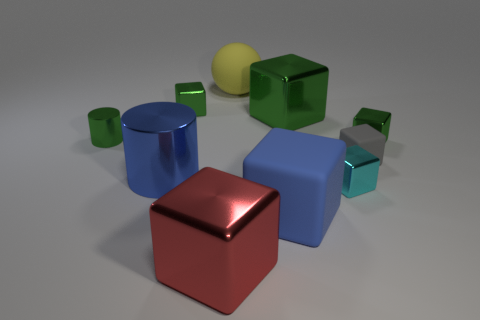Is the material of the red object the same as the big ball?
Make the answer very short. No. What shape is the blue object that is the same material as the green cylinder?
Make the answer very short. Cylinder. Is there any other thing that has the same color as the small metallic cylinder?
Give a very brief answer. Yes. What is the material of the tiny gray thing that is the same shape as the large blue matte object?
Your response must be concise. Rubber. What number of other things are the same size as the sphere?
Provide a succinct answer. 4. There is a object that is the same color as the large shiny cylinder; what size is it?
Your answer should be compact. Large. Do the metal object that is in front of the tiny cyan shiny cube and the gray object have the same shape?
Provide a succinct answer. Yes. How many other objects are there of the same shape as the big yellow rubber object?
Offer a very short reply. 0. What is the shape of the metal thing right of the tiny rubber object?
Your answer should be compact. Cube. Is there a object that has the same material as the small cyan cube?
Offer a very short reply. Yes. 